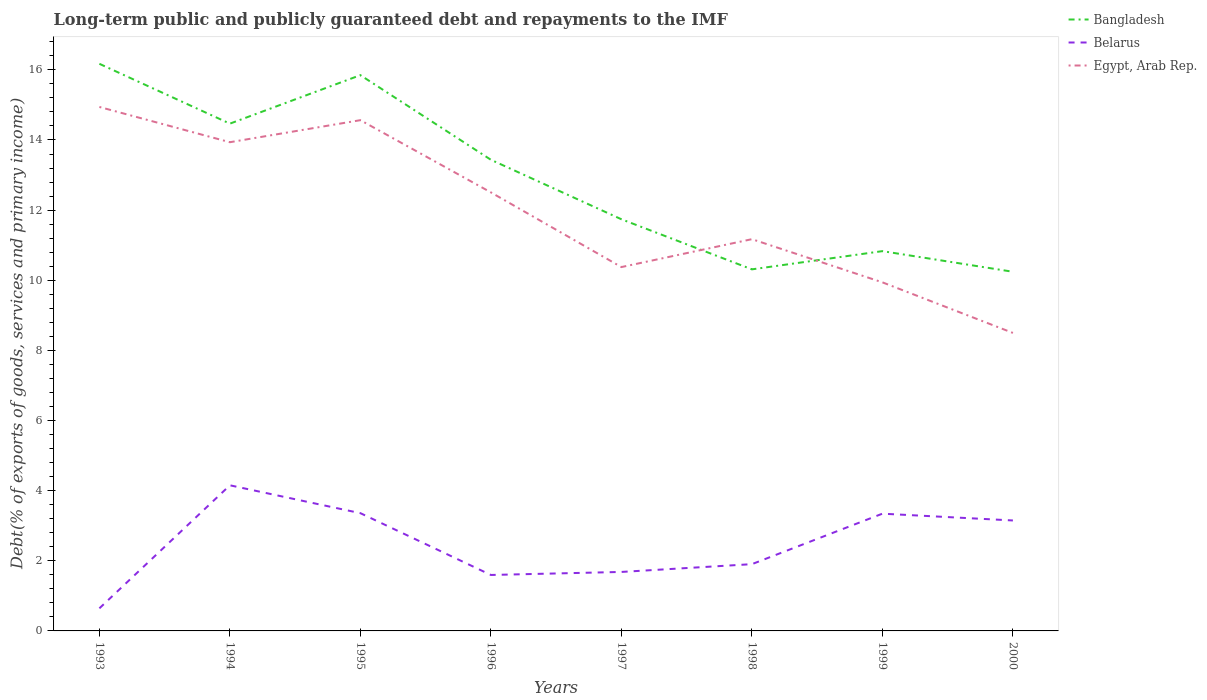How many different coloured lines are there?
Provide a short and direct response. 3. Across all years, what is the maximum debt and repayments in Egypt, Arab Rep.?
Make the answer very short. 8.5. What is the total debt and repayments in Egypt, Arab Rep. in the graph?
Make the answer very short. 6.07. What is the difference between the highest and the second highest debt and repayments in Bangladesh?
Offer a very short reply. 5.93. What is the difference between the highest and the lowest debt and repayments in Bangladesh?
Offer a very short reply. 4. How many years are there in the graph?
Keep it short and to the point. 8. Does the graph contain any zero values?
Offer a very short reply. No. How are the legend labels stacked?
Ensure brevity in your answer.  Vertical. What is the title of the graph?
Offer a terse response. Long-term public and publicly guaranteed debt and repayments to the IMF. What is the label or title of the X-axis?
Provide a short and direct response. Years. What is the label or title of the Y-axis?
Give a very brief answer. Debt(% of exports of goods, services and primary income). What is the Debt(% of exports of goods, services and primary income) of Bangladesh in 1993?
Your response must be concise. 16.17. What is the Debt(% of exports of goods, services and primary income) in Belarus in 1993?
Ensure brevity in your answer.  0.64. What is the Debt(% of exports of goods, services and primary income) of Egypt, Arab Rep. in 1993?
Your answer should be compact. 14.94. What is the Debt(% of exports of goods, services and primary income) of Bangladesh in 1994?
Offer a terse response. 14.47. What is the Debt(% of exports of goods, services and primary income) of Belarus in 1994?
Ensure brevity in your answer.  4.15. What is the Debt(% of exports of goods, services and primary income) of Egypt, Arab Rep. in 1994?
Provide a succinct answer. 13.94. What is the Debt(% of exports of goods, services and primary income) in Bangladesh in 1995?
Provide a succinct answer. 15.85. What is the Debt(% of exports of goods, services and primary income) in Belarus in 1995?
Offer a very short reply. 3.36. What is the Debt(% of exports of goods, services and primary income) of Egypt, Arab Rep. in 1995?
Offer a terse response. 14.56. What is the Debt(% of exports of goods, services and primary income) of Bangladesh in 1996?
Provide a short and direct response. 13.44. What is the Debt(% of exports of goods, services and primary income) of Belarus in 1996?
Give a very brief answer. 1.6. What is the Debt(% of exports of goods, services and primary income) of Egypt, Arab Rep. in 1996?
Ensure brevity in your answer.  12.51. What is the Debt(% of exports of goods, services and primary income) in Bangladesh in 1997?
Make the answer very short. 11.74. What is the Debt(% of exports of goods, services and primary income) in Belarus in 1997?
Your response must be concise. 1.68. What is the Debt(% of exports of goods, services and primary income) of Egypt, Arab Rep. in 1997?
Your response must be concise. 10.38. What is the Debt(% of exports of goods, services and primary income) in Bangladesh in 1998?
Ensure brevity in your answer.  10.31. What is the Debt(% of exports of goods, services and primary income) in Belarus in 1998?
Provide a short and direct response. 1.9. What is the Debt(% of exports of goods, services and primary income) in Egypt, Arab Rep. in 1998?
Provide a short and direct response. 11.17. What is the Debt(% of exports of goods, services and primary income) of Bangladesh in 1999?
Your response must be concise. 10.83. What is the Debt(% of exports of goods, services and primary income) of Belarus in 1999?
Provide a short and direct response. 3.34. What is the Debt(% of exports of goods, services and primary income) of Egypt, Arab Rep. in 1999?
Your answer should be very brief. 9.94. What is the Debt(% of exports of goods, services and primary income) in Bangladesh in 2000?
Offer a terse response. 10.24. What is the Debt(% of exports of goods, services and primary income) in Belarus in 2000?
Keep it short and to the point. 3.15. What is the Debt(% of exports of goods, services and primary income) in Egypt, Arab Rep. in 2000?
Keep it short and to the point. 8.5. Across all years, what is the maximum Debt(% of exports of goods, services and primary income) of Bangladesh?
Your answer should be very brief. 16.17. Across all years, what is the maximum Debt(% of exports of goods, services and primary income) of Belarus?
Give a very brief answer. 4.15. Across all years, what is the maximum Debt(% of exports of goods, services and primary income) in Egypt, Arab Rep.?
Keep it short and to the point. 14.94. Across all years, what is the minimum Debt(% of exports of goods, services and primary income) of Bangladesh?
Offer a very short reply. 10.24. Across all years, what is the minimum Debt(% of exports of goods, services and primary income) of Belarus?
Your response must be concise. 0.64. Across all years, what is the minimum Debt(% of exports of goods, services and primary income) in Egypt, Arab Rep.?
Your answer should be compact. 8.5. What is the total Debt(% of exports of goods, services and primary income) of Bangladesh in the graph?
Offer a very short reply. 103.04. What is the total Debt(% of exports of goods, services and primary income) of Belarus in the graph?
Provide a short and direct response. 19.83. What is the total Debt(% of exports of goods, services and primary income) of Egypt, Arab Rep. in the graph?
Your answer should be very brief. 95.93. What is the difference between the Debt(% of exports of goods, services and primary income) in Bangladesh in 1993 and that in 1994?
Provide a short and direct response. 1.71. What is the difference between the Debt(% of exports of goods, services and primary income) of Belarus in 1993 and that in 1994?
Your response must be concise. -3.51. What is the difference between the Debt(% of exports of goods, services and primary income) in Egypt, Arab Rep. in 1993 and that in 1994?
Keep it short and to the point. 1.01. What is the difference between the Debt(% of exports of goods, services and primary income) of Bangladesh in 1993 and that in 1995?
Your answer should be compact. 0.32. What is the difference between the Debt(% of exports of goods, services and primary income) of Belarus in 1993 and that in 1995?
Your answer should be very brief. -2.71. What is the difference between the Debt(% of exports of goods, services and primary income) of Egypt, Arab Rep. in 1993 and that in 1995?
Ensure brevity in your answer.  0.38. What is the difference between the Debt(% of exports of goods, services and primary income) in Bangladesh in 1993 and that in 1996?
Keep it short and to the point. 2.74. What is the difference between the Debt(% of exports of goods, services and primary income) in Belarus in 1993 and that in 1996?
Your response must be concise. -0.95. What is the difference between the Debt(% of exports of goods, services and primary income) in Egypt, Arab Rep. in 1993 and that in 1996?
Make the answer very short. 2.44. What is the difference between the Debt(% of exports of goods, services and primary income) in Bangladesh in 1993 and that in 1997?
Keep it short and to the point. 4.43. What is the difference between the Debt(% of exports of goods, services and primary income) of Belarus in 1993 and that in 1997?
Make the answer very short. -1.04. What is the difference between the Debt(% of exports of goods, services and primary income) in Egypt, Arab Rep. in 1993 and that in 1997?
Your answer should be very brief. 4.57. What is the difference between the Debt(% of exports of goods, services and primary income) in Bangladesh in 1993 and that in 1998?
Give a very brief answer. 5.86. What is the difference between the Debt(% of exports of goods, services and primary income) in Belarus in 1993 and that in 1998?
Provide a short and direct response. -1.26. What is the difference between the Debt(% of exports of goods, services and primary income) in Egypt, Arab Rep. in 1993 and that in 1998?
Your answer should be compact. 3.77. What is the difference between the Debt(% of exports of goods, services and primary income) of Bangladesh in 1993 and that in 1999?
Offer a very short reply. 5.34. What is the difference between the Debt(% of exports of goods, services and primary income) of Belarus in 1993 and that in 1999?
Make the answer very short. -2.7. What is the difference between the Debt(% of exports of goods, services and primary income) of Egypt, Arab Rep. in 1993 and that in 1999?
Give a very brief answer. 5. What is the difference between the Debt(% of exports of goods, services and primary income) in Bangladesh in 1993 and that in 2000?
Offer a very short reply. 5.93. What is the difference between the Debt(% of exports of goods, services and primary income) in Belarus in 1993 and that in 2000?
Ensure brevity in your answer.  -2.51. What is the difference between the Debt(% of exports of goods, services and primary income) of Egypt, Arab Rep. in 1993 and that in 2000?
Make the answer very short. 6.44. What is the difference between the Debt(% of exports of goods, services and primary income) in Bangladesh in 1994 and that in 1995?
Your response must be concise. -1.38. What is the difference between the Debt(% of exports of goods, services and primary income) of Belarus in 1994 and that in 1995?
Your answer should be very brief. 0.79. What is the difference between the Debt(% of exports of goods, services and primary income) of Egypt, Arab Rep. in 1994 and that in 1995?
Keep it short and to the point. -0.63. What is the difference between the Debt(% of exports of goods, services and primary income) of Bangladesh in 1994 and that in 1996?
Provide a succinct answer. 1.03. What is the difference between the Debt(% of exports of goods, services and primary income) in Belarus in 1994 and that in 1996?
Your answer should be very brief. 2.56. What is the difference between the Debt(% of exports of goods, services and primary income) of Egypt, Arab Rep. in 1994 and that in 1996?
Your answer should be compact. 1.43. What is the difference between the Debt(% of exports of goods, services and primary income) of Bangladesh in 1994 and that in 1997?
Provide a succinct answer. 2.73. What is the difference between the Debt(% of exports of goods, services and primary income) in Belarus in 1994 and that in 1997?
Your response must be concise. 2.47. What is the difference between the Debt(% of exports of goods, services and primary income) in Egypt, Arab Rep. in 1994 and that in 1997?
Ensure brevity in your answer.  3.56. What is the difference between the Debt(% of exports of goods, services and primary income) of Bangladesh in 1994 and that in 1998?
Your answer should be compact. 4.16. What is the difference between the Debt(% of exports of goods, services and primary income) in Belarus in 1994 and that in 1998?
Make the answer very short. 2.25. What is the difference between the Debt(% of exports of goods, services and primary income) of Egypt, Arab Rep. in 1994 and that in 1998?
Offer a very short reply. 2.76. What is the difference between the Debt(% of exports of goods, services and primary income) of Bangladesh in 1994 and that in 1999?
Ensure brevity in your answer.  3.64. What is the difference between the Debt(% of exports of goods, services and primary income) in Belarus in 1994 and that in 1999?
Offer a very short reply. 0.81. What is the difference between the Debt(% of exports of goods, services and primary income) in Egypt, Arab Rep. in 1994 and that in 1999?
Offer a terse response. 4. What is the difference between the Debt(% of exports of goods, services and primary income) of Bangladesh in 1994 and that in 2000?
Keep it short and to the point. 4.22. What is the difference between the Debt(% of exports of goods, services and primary income) in Belarus in 1994 and that in 2000?
Your response must be concise. 1. What is the difference between the Debt(% of exports of goods, services and primary income) of Egypt, Arab Rep. in 1994 and that in 2000?
Give a very brief answer. 5.44. What is the difference between the Debt(% of exports of goods, services and primary income) in Bangladesh in 1995 and that in 1996?
Offer a terse response. 2.41. What is the difference between the Debt(% of exports of goods, services and primary income) in Belarus in 1995 and that in 1996?
Your answer should be compact. 1.76. What is the difference between the Debt(% of exports of goods, services and primary income) in Egypt, Arab Rep. in 1995 and that in 1996?
Give a very brief answer. 2.06. What is the difference between the Debt(% of exports of goods, services and primary income) in Bangladesh in 1995 and that in 1997?
Offer a very short reply. 4.11. What is the difference between the Debt(% of exports of goods, services and primary income) of Belarus in 1995 and that in 1997?
Ensure brevity in your answer.  1.68. What is the difference between the Debt(% of exports of goods, services and primary income) of Egypt, Arab Rep. in 1995 and that in 1997?
Give a very brief answer. 4.19. What is the difference between the Debt(% of exports of goods, services and primary income) of Bangladesh in 1995 and that in 1998?
Your answer should be very brief. 5.54. What is the difference between the Debt(% of exports of goods, services and primary income) in Belarus in 1995 and that in 1998?
Provide a succinct answer. 1.45. What is the difference between the Debt(% of exports of goods, services and primary income) in Egypt, Arab Rep. in 1995 and that in 1998?
Give a very brief answer. 3.39. What is the difference between the Debt(% of exports of goods, services and primary income) in Bangladesh in 1995 and that in 1999?
Give a very brief answer. 5.02. What is the difference between the Debt(% of exports of goods, services and primary income) in Belarus in 1995 and that in 1999?
Make the answer very short. 0.01. What is the difference between the Debt(% of exports of goods, services and primary income) in Egypt, Arab Rep. in 1995 and that in 1999?
Provide a short and direct response. 4.62. What is the difference between the Debt(% of exports of goods, services and primary income) of Bangladesh in 1995 and that in 2000?
Provide a short and direct response. 5.61. What is the difference between the Debt(% of exports of goods, services and primary income) in Belarus in 1995 and that in 2000?
Ensure brevity in your answer.  0.21. What is the difference between the Debt(% of exports of goods, services and primary income) in Egypt, Arab Rep. in 1995 and that in 2000?
Ensure brevity in your answer.  6.07. What is the difference between the Debt(% of exports of goods, services and primary income) of Bangladesh in 1996 and that in 1997?
Give a very brief answer. 1.7. What is the difference between the Debt(% of exports of goods, services and primary income) in Belarus in 1996 and that in 1997?
Your answer should be very brief. -0.09. What is the difference between the Debt(% of exports of goods, services and primary income) of Egypt, Arab Rep. in 1996 and that in 1997?
Make the answer very short. 2.13. What is the difference between the Debt(% of exports of goods, services and primary income) of Bangladesh in 1996 and that in 1998?
Your answer should be compact. 3.12. What is the difference between the Debt(% of exports of goods, services and primary income) in Belarus in 1996 and that in 1998?
Make the answer very short. -0.31. What is the difference between the Debt(% of exports of goods, services and primary income) of Egypt, Arab Rep. in 1996 and that in 1998?
Keep it short and to the point. 1.33. What is the difference between the Debt(% of exports of goods, services and primary income) in Bangladesh in 1996 and that in 1999?
Provide a short and direct response. 2.61. What is the difference between the Debt(% of exports of goods, services and primary income) in Belarus in 1996 and that in 1999?
Give a very brief answer. -1.75. What is the difference between the Debt(% of exports of goods, services and primary income) in Egypt, Arab Rep. in 1996 and that in 1999?
Offer a very short reply. 2.56. What is the difference between the Debt(% of exports of goods, services and primary income) of Bangladesh in 1996 and that in 2000?
Your response must be concise. 3.19. What is the difference between the Debt(% of exports of goods, services and primary income) of Belarus in 1996 and that in 2000?
Provide a short and direct response. -1.55. What is the difference between the Debt(% of exports of goods, services and primary income) of Egypt, Arab Rep. in 1996 and that in 2000?
Ensure brevity in your answer.  4.01. What is the difference between the Debt(% of exports of goods, services and primary income) of Bangladesh in 1997 and that in 1998?
Give a very brief answer. 1.43. What is the difference between the Debt(% of exports of goods, services and primary income) in Belarus in 1997 and that in 1998?
Make the answer very short. -0.22. What is the difference between the Debt(% of exports of goods, services and primary income) of Egypt, Arab Rep. in 1997 and that in 1998?
Give a very brief answer. -0.8. What is the difference between the Debt(% of exports of goods, services and primary income) of Bangladesh in 1997 and that in 1999?
Keep it short and to the point. 0.91. What is the difference between the Debt(% of exports of goods, services and primary income) in Belarus in 1997 and that in 1999?
Provide a short and direct response. -1.66. What is the difference between the Debt(% of exports of goods, services and primary income) in Egypt, Arab Rep. in 1997 and that in 1999?
Offer a terse response. 0.44. What is the difference between the Debt(% of exports of goods, services and primary income) in Bangladesh in 1997 and that in 2000?
Your answer should be very brief. 1.5. What is the difference between the Debt(% of exports of goods, services and primary income) in Belarus in 1997 and that in 2000?
Make the answer very short. -1.47. What is the difference between the Debt(% of exports of goods, services and primary income) in Egypt, Arab Rep. in 1997 and that in 2000?
Make the answer very short. 1.88. What is the difference between the Debt(% of exports of goods, services and primary income) of Bangladesh in 1998 and that in 1999?
Your response must be concise. -0.52. What is the difference between the Debt(% of exports of goods, services and primary income) in Belarus in 1998 and that in 1999?
Offer a terse response. -1.44. What is the difference between the Debt(% of exports of goods, services and primary income) of Egypt, Arab Rep. in 1998 and that in 1999?
Offer a terse response. 1.23. What is the difference between the Debt(% of exports of goods, services and primary income) in Bangladesh in 1998 and that in 2000?
Offer a terse response. 0.07. What is the difference between the Debt(% of exports of goods, services and primary income) in Belarus in 1998 and that in 2000?
Provide a short and direct response. -1.25. What is the difference between the Debt(% of exports of goods, services and primary income) of Egypt, Arab Rep. in 1998 and that in 2000?
Provide a succinct answer. 2.67. What is the difference between the Debt(% of exports of goods, services and primary income) in Bangladesh in 1999 and that in 2000?
Offer a very short reply. 0.59. What is the difference between the Debt(% of exports of goods, services and primary income) of Belarus in 1999 and that in 2000?
Give a very brief answer. 0.19. What is the difference between the Debt(% of exports of goods, services and primary income) of Egypt, Arab Rep. in 1999 and that in 2000?
Your answer should be very brief. 1.44. What is the difference between the Debt(% of exports of goods, services and primary income) in Bangladesh in 1993 and the Debt(% of exports of goods, services and primary income) in Belarus in 1994?
Your response must be concise. 12.02. What is the difference between the Debt(% of exports of goods, services and primary income) in Bangladesh in 1993 and the Debt(% of exports of goods, services and primary income) in Egypt, Arab Rep. in 1994?
Your answer should be very brief. 2.24. What is the difference between the Debt(% of exports of goods, services and primary income) in Belarus in 1993 and the Debt(% of exports of goods, services and primary income) in Egypt, Arab Rep. in 1994?
Give a very brief answer. -13.29. What is the difference between the Debt(% of exports of goods, services and primary income) in Bangladesh in 1993 and the Debt(% of exports of goods, services and primary income) in Belarus in 1995?
Give a very brief answer. 12.81. What is the difference between the Debt(% of exports of goods, services and primary income) of Bangladesh in 1993 and the Debt(% of exports of goods, services and primary income) of Egypt, Arab Rep. in 1995?
Ensure brevity in your answer.  1.61. What is the difference between the Debt(% of exports of goods, services and primary income) of Belarus in 1993 and the Debt(% of exports of goods, services and primary income) of Egypt, Arab Rep. in 1995?
Your answer should be compact. -13.92. What is the difference between the Debt(% of exports of goods, services and primary income) in Bangladesh in 1993 and the Debt(% of exports of goods, services and primary income) in Belarus in 1996?
Your answer should be compact. 14.58. What is the difference between the Debt(% of exports of goods, services and primary income) in Bangladesh in 1993 and the Debt(% of exports of goods, services and primary income) in Egypt, Arab Rep. in 1996?
Provide a succinct answer. 3.67. What is the difference between the Debt(% of exports of goods, services and primary income) in Belarus in 1993 and the Debt(% of exports of goods, services and primary income) in Egypt, Arab Rep. in 1996?
Offer a very short reply. -11.86. What is the difference between the Debt(% of exports of goods, services and primary income) in Bangladesh in 1993 and the Debt(% of exports of goods, services and primary income) in Belarus in 1997?
Offer a terse response. 14.49. What is the difference between the Debt(% of exports of goods, services and primary income) in Bangladesh in 1993 and the Debt(% of exports of goods, services and primary income) in Egypt, Arab Rep. in 1997?
Keep it short and to the point. 5.8. What is the difference between the Debt(% of exports of goods, services and primary income) in Belarus in 1993 and the Debt(% of exports of goods, services and primary income) in Egypt, Arab Rep. in 1997?
Your response must be concise. -9.73. What is the difference between the Debt(% of exports of goods, services and primary income) in Bangladesh in 1993 and the Debt(% of exports of goods, services and primary income) in Belarus in 1998?
Your answer should be compact. 14.27. What is the difference between the Debt(% of exports of goods, services and primary income) in Bangladesh in 1993 and the Debt(% of exports of goods, services and primary income) in Egypt, Arab Rep. in 1998?
Your response must be concise. 5. What is the difference between the Debt(% of exports of goods, services and primary income) of Belarus in 1993 and the Debt(% of exports of goods, services and primary income) of Egypt, Arab Rep. in 1998?
Your answer should be compact. -10.53. What is the difference between the Debt(% of exports of goods, services and primary income) in Bangladesh in 1993 and the Debt(% of exports of goods, services and primary income) in Belarus in 1999?
Offer a terse response. 12.83. What is the difference between the Debt(% of exports of goods, services and primary income) of Bangladesh in 1993 and the Debt(% of exports of goods, services and primary income) of Egypt, Arab Rep. in 1999?
Provide a succinct answer. 6.23. What is the difference between the Debt(% of exports of goods, services and primary income) in Belarus in 1993 and the Debt(% of exports of goods, services and primary income) in Egypt, Arab Rep. in 1999?
Your answer should be compact. -9.3. What is the difference between the Debt(% of exports of goods, services and primary income) in Bangladesh in 1993 and the Debt(% of exports of goods, services and primary income) in Belarus in 2000?
Keep it short and to the point. 13.02. What is the difference between the Debt(% of exports of goods, services and primary income) of Bangladesh in 1993 and the Debt(% of exports of goods, services and primary income) of Egypt, Arab Rep. in 2000?
Your answer should be compact. 7.67. What is the difference between the Debt(% of exports of goods, services and primary income) of Belarus in 1993 and the Debt(% of exports of goods, services and primary income) of Egypt, Arab Rep. in 2000?
Make the answer very short. -7.85. What is the difference between the Debt(% of exports of goods, services and primary income) of Bangladesh in 1994 and the Debt(% of exports of goods, services and primary income) of Belarus in 1995?
Ensure brevity in your answer.  11.11. What is the difference between the Debt(% of exports of goods, services and primary income) of Bangladesh in 1994 and the Debt(% of exports of goods, services and primary income) of Egypt, Arab Rep. in 1995?
Keep it short and to the point. -0.1. What is the difference between the Debt(% of exports of goods, services and primary income) in Belarus in 1994 and the Debt(% of exports of goods, services and primary income) in Egypt, Arab Rep. in 1995?
Your response must be concise. -10.41. What is the difference between the Debt(% of exports of goods, services and primary income) of Bangladesh in 1994 and the Debt(% of exports of goods, services and primary income) of Belarus in 1996?
Give a very brief answer. 12.87. What is the difference between the Debt(% of exports of goods, services and primary income) of Bangladesh in 1994 and the Debt(% of exports of goods, services and primary income) of Egypt, Arab Rep. in 1996?
Keep it short and to the point. 1.96. What is the difference between the Debt(% of exports of goods, services and primary income) of Belarus in 1994 and the Debt(% of exports of goods, services and primary income) of Egypt, Arab Rep. in 1996?
Your answer should be very brief. -8.35. What is the difference between the Debt(% of exports of goods, services and primary income) in Bangladesh in 1994 and the Debt(% of exports of goods, services and primary income) in Belarus in 1997?
Offer a terse response. 12.78. What is the difference between the Debt(% of exports of goods, services and primary income) of Bangladesh in 1994 and the Debt(% of exports of goods, services and primary income) of Egypt, Arab Rep. in 1997?
Keep it short and to the point. 4.09. What is the difference between the Debt(% of exports of goods, services and primary income) in Belarus in 1994 and the Debt(% of exports of goods, services and primary income) in Egypt, Arab Rep. in 1997?
Your answer should be compact. -6.22. What is the difference between the Debt(% of exports of goods, services and primary income) of Bangladesh in 1994 and the Debt(% of exports of goods, services and primary income) of Belarus in 1998?
Keep it short and to the point. 12.56. What is the difference between the Debt(% of exports of goods, services and primary income) of Bangladesh in 1994 and the Debt(% of exports of goods, services and primary income) of Egypt, Arab Rep. in 1998?
Make the answer very short. 3.29. What is the difference between the Debt(% of exports of goods, services and primary income) of Belarus in 1994 and the Debt(% of exports of goods, services and primary income) of Egypt, Arab Rep. in 1998?
Keep it short and to the point. -7.02. What is the difference between the Debt(% of exports of goods, services and primary income) in Bangladesh in 1994 and the Debt(% of exports of goods, services and primary income) in Belarus in 1999?
Your response must be concise. 11.12. What is the difference between the Debt(% of exports of goods, services and primary income) in Bangladesh in 1994 and the Debt(% of exports of goods, services and primary income) in Egypt, Arab Rep. in 1999?
Your answer should be very brief. 4.53. What is the difference between the Debt(% of exports of goods, services and primary income) in Belarus in 1994 and the Debt(% of exports of goods, services and primary income) in Egypt, Arab Rep. in 1999?
Make the answer very short. -5.79. What is the difference between the Debt(% of exports of goods, services and primary income) in Bangladesh in 1994 and the Debt(% of exports of goods, services and primary income) in Belarus in 2000?
Your answer should be very brief. 11.32. What is the difference between the Debt(% of exports of goods, services and primary income) of Bangladesh in 1994 and the Debt(% of exports of goods, services and primary income) of Egypt, Arab Rep. in 2000?
Offer a terse response. 5.97. What is the difference between the Debt(% of exports of goods, services and primary income) of Belarus in 1994 and the Debt(% of exports of goods, services and primary income) of Egypt, Arab Rep. in 2000?
Ensure brevity in your answer.  -4.35. What is the difference between the Debt(% of exports of goods, services and primary income) of Bangladesh in 1995 and the Debt(% of exports of goods, services and primary income) of Belarus in 1996?
Keep it short and to the point. 14.25. What is the difference between the Debt(% of exports of goods, services and primary income) in Bangladesh in 1995 and the Debt(% of exports of goods, services and primary income) in Egypt, Arab Rep. in 1996?
Your answer should be very brief. 3.34. What is the difference between the Debt(% of exports of goods, services and primary income) in Belarus in 1995 and the Debt(% of exports of goods, services and primary income) in Egypt, Arab Rep. in 1996?
Provide a short and direct response. -9.15. What is the difference between the Debt(% of exports of goods, services and primary income) of Bangladesh in 1995 and the Debt(% of exports of goods, services and primary income) of Belarus in 1997?
Provide a short and direct response. 14.17. What is the difference between the Debt(% of exports of goods, services and primary income) in Bangladesh in 1995 and the Debt(% of exports of goods, services and primary income) in Egypt, Arab Rep. in 1997?
Provide a short and direct response. 5.47. What is the difference between the Debt(% of exports of goods, services and primary income) in Belarus in 1995 and the Debt(% of exports of goods, services and primary income) in Egypt, Arab Rep. in 1997?
Your answer should be very brief. -7.02. What is the difference between the Debt(% of exports of goods, services and primary income) of Bangladesh in 1995 and the Debt(% of exports of goods, services and primary income) of Belarus in 1998?
Give a very brief answer. 13.94. What is the difference between the Debt(% of exports of goods, services and primary income) in Bangladesh in 1995 and the Debt(% of exports of goods, services and primary income) in Egypt, Arab Rep. in 1998?
Give a very brief answer. 4.68. What is the difference between the Debt(% of exports of goods, services and primary income) in Belarus in 1995 and the Debt(% of exports of goods, services and primary income) in Egypt, Arab Rep. in 1998?
Make the answer very short. -7.81. What is the difference between the Debt(% of exports of goods, services and primary income) of Bangladesh in 1995 and the Debt(% of exports of goods, services and primary income) of Belarus in 1999?
Provide a short and direct response. 12.5. What is the difference between the Debt(% of exports of goods, services and primary income) in Bangladesh in 1995 and the Debt(% of exports of goods, services and primary income) in Egypt, Arab Rep. in 1999?
Keep it short and to the point. 5.91. What is the difference between the Debt(% of exports of goods, services and primary income) in Belarus in 1995 and the Debt(% of exports of goods, services and primary income) in Egypt, Arab Rep. in 1999?
Your answer should be very brief. -6.58. What is the difference between the Debt(% of exports of goods, services and primary income) in Bangladesh in 1995 and the Debt(% of exports of goods, services and primary income) in Belarus in 2000?
Offer a very short reply. 12.7. What is the difference between the Debt(% of exports of goods, services and primary income) of Bangladesh in 1995 and the Debt(% of exports of goods, services and primary income) of Egypt, Arab Rep. in 2000?
Ensure brevity in your answer.  7.35. What is the difference between the Debt(% of exports of goods, services and primary income) in Belarus in 1995 and the Debt(% of exports of goods, services and primary income) in Egypt, Arab Rep. in 2000?
Keep it short and to the point. -5.14. What is the difference between the Debt(% of exports of goods, services and primary income) in Bangladesh in 1996 and the Debt(% of exports of goods, services and primary income) in Belarus in 1997?
Give a very brief answer. 11.75. What is the difference between the Debt(% of exports of goods, services and primary income) of Bangladesh in 1996 and the Debt(% of exports of goods, services and primary income) of Egypt, Arab Rep. in 1997?
Provide a succinct answer. 3.06. What is the difference between the Debt(% of exports of goods, services and primary income) in Belarus in 1996 and the Debt(% of exports of goods, services and primary income) in Egypt, Arab Rep. in 1997?
Provide a short and direct response. -8.78. What is the difference between the Debt(% of exports of goods, services and primary income) of Bangladesh in 1996 and the Debt(% of exports of goods, services and primary income) of Belarus in 1998?
Ensure brevity in your answer.  11.53. What is the difference between the Debt(% of exports of goods, services and primary income) of Bangladesh in 1996 and the Debt(% of exports of goods, services and primary income) of Egypt, Arab Rep. in 1998?
Your answer should be compact. 2.26. What is the difference between the Debt(% of exports of goods, services and primary income) of Belarus in 1996 and the Debt(% of exports of goods, services and primary income) of Egypt, Arab Rep. in 1998?
Make the answer very short. -9.58. What is the difference between the Debt(% of exports of goods, services and primary income) of Bangladesh in 1996 and the Debt(% of exports of goods, services and primary income) of Belarus in 1999?
Your response must be concise. 10.09. What is the difference between the Debt(% of exports of goods, services and primary income) of Bangladesh in 1996 and the Debt(% of exports of goods, services and primary income) of Egypt, Arab Rep. in 1999?
Your answer should be compact. 3.5. What is the difference between the Debt(% of exports of goods, services and primary income) of Belarus in 1996 and the Debt(% of exports of goods, services and primary income) of Egypt, Arab Rep. in 1999?
Offer a terse response. -8.34. What is the difference between the Debt(% of exports of goods, services and primary income) of Bangladesh in 1996 and the Debt(% of exports of goods, services and primary income) of Belarus in 2000?
Your answer should be compact. 10.29. What is the difference between the Debt(% of exports of goods, services and primary income) of Bangladesh in 1996 and the Debt(% of exports of goods, services and primary income) of Egypt, Arab Rep. in 2000?
Give a very brief answer. 4.94. What is the difference between the Debt(% of exports of goods, services and primary income) of Belarus in 1996 and the Debt(% of exports of goods, services and primary income) of Egypt, Arab Rep. in 2000?
Your answer should be very brief. -6.9. What is the difference between the Debt(% of exports of goods, services and primary income) of Bangladesh in 1997 and the Debt(% of exports of goods, services and primary income) of Belarus in 1998?
Make the answer very short. 9.84. What is the difference between the Debt(% of exports of goods, services and primary income) of Bangladesh in 1997 and the Debt(% of exports of goods, services and primary income) of Egypt, Arab Rep. in 1998?
Make the answer very short. 0.57. What is the difference between the Debt(% of exports of goods, services and primary income) of Belarus in 1997 and the Debt(% of exports of goods, services and primary income) of Egypt, Arab Rep. in 1998?
Your answer should be compact. -9.49. What is the difference between the Debt(% of exports of goods, services and primary income) of Bangladesh in 1997 and the Debt(% of exports of goods, services and primary income) of Belarus in 1999?
Make the answer very short. 8.4. What is the difference between the Debt(% of exports of goods, services and primary income) of Bangladesh in 1997 and the Debt(% of exports of goods, services and primary income) of Egypt, Arab Rep. in 1999?
Provide a short and direct response. 1.8. What is the difference between the Debt(% of exports of goods, services and primary income) of Belarus in 1997 and the Debt(% of exports of goods, services and primary income) of Egypt, Arab Rep. in 1999?
Offer a very short reply. -8.26. What is the difference between the Debt(% of exports of goods, services and primary income) of Bangladesh in 1997 and the Debt(% of exports of goods, services and primary income) of Belarus in 2000?
Your response must be concise. 8.59. What is the difference between the Debt(% of exports of goods, services and primary income) in Bangladesh in 1997 and the Debt(% of exports of goods, services and primary income) in Egypt, Arab Rep. in 2000?
Your response must be concise. 3.24. What is the difference between the Debt(% of exports of goods, services and primary income) of Belarus in 1997 and the Debt(% of exports of goods, services and primary income) of Egypt, Arab Rep. in 2000?
Your answer should be very brief. -6.82. What is the difference between the Debt(% of exports of goods, services and primary income) of Bangladesh in 1998 and the Debt(% of exports of goods, services and primary income) of Belarus in 1999?
Ensure brevity in your answer.  6.97. What is the difference between the Debt(% of exports of goods, services and primary income) in Bangladesh in 1998 and the Debt(% of exports of goods, services and primary income) in Egypt, Arab Rep. in 1999?
Provide a succinct answer. 0.37. What is the difference between the Debt(% of exports of goods, services and primary income) in Belarus in 1998 and the Debt(% of exports of goods, services and primary income) in Egypt, Arab Rep. in 1999?
Give a very brief answer. -8.04. What is the difference between the Debt(% of exports of goods, services and primary income) of Bangladesh in 1998 and the Debt(% of exports of goods, services and primary income) of Belarus in 2000?
Provide a short and direct response. 7.16. What is the difference between the Debt(% of exports of goods, services and primary income) of Bangladesh in 1998 and the Debt(% of exports of goods, services and primary income) of Egypt, Arab Rep. in 2000?
Your answer should be compact. 1.81. What is the difference between the Debt(% of exports of goods, services and primary income) of Belarus in 1998 and the Debt(% of exports of goods, services and primary income) of Egypt, Arab Rep. in 2000?
Provide a succinct answer. -6.59. What is the difference between the Debt(% of exports of goods, services and primary income) of Bangladesh in 1999 and the Debt(% of exports of goods, services and primary income) of Belarus in 2000?
Make the answer very short. 7.68. What is the difference between the Debt(% of exports of goods, services and primary income) of Bangladesh in 1999 and the Debt(% of exports of goods, services and primary income) of Egypt, Arab Rep. in 2000?
Keep it short and to the point. 2.33. What is the difference between the Debt(% of exports of goods, services and primary income) in Belarus in 1999 and the Debt(% of exports of goods, services and primary income) in Egypt, Arab Rep. in 2000?
Your answer should be compact. -5.15. What is the average Debt(% of exports of goods, services and primary income) in Bangladesh per year?
Make the answer very short. 12.88. What is the average Debt(% of exports of goods, services and primary income) in Belarus per year?
Keep it short and to the point. 2.48. What is the average Debt(% of exports of goods, services and primary income) of Egypt, Arab Rep. per year?
Make the answer very short. 11.99. In the year 1993, what is the difference between the Debt(% of exports of goods, services and primary income) of Bangladesh and Debt(% of exports of goods, services and primary income) of Belarus?
Your response must be concise. 15.53. In the year 1993, what is the difference between the Debt(% of exports of goods, services and primary income) in Bangladesh and Debt(% of exports of goods, services and primary income) in Egypt, Arab Rep.?
Your response must be concise. 1.23. In the year 1993, what is the difference between the Debt(% of exports of goods, services and primary income) of Belarus and Debt(% of exports of goods, services and primary income) of Egypt, Arab Rep.?
Provide a short and direct response. -14.3. In the year 1994, what is the difference between the Debt(% of exports of goods, services and primary income) in Bangladesh and Debt(% of exports of goods, services and primary income) in Belarus?
Your answer should be very brief. 10.31. In the year 1994, what is the difference between the Debt(% of exports of goods, services and primary income) of Bangladesh and Debt(% of exports of goods, services and primary income) of Egypt, Arab Rep.?
Make the answer very short. 0.53. In the year 1994, what is the difference between the Debt(% of exports of goods, services and primary income) in Belarus and Debt(% of exports of goods, services and primary income) in Egypt, Arab Rep.?
Provide a short and direct response. -9.78. In the year 1995, what is the difference between the Debt(% of exports of goods, services and primary income) in Bangladesh and Debt(% of exports of goods, services and primary income) in Belarus?
Offer a very short reply. 12.49. In the year 1995, what is the difference between the Debt(% of exports of goods, services and primary income) in Bangladesh and Debt(% of exports of goods, services and primary income) in Egypt, Arab Rep.?
Provide a short and direct response. 1.28. In the year 1995, what is the difference between the Debt(% of exports of goods, services and primary income) in Belarus and Debt(% of exports of goods, services and primary income) in Egypt, Arab Rep.?
Offer a terse response. -11.21. In the year 1996, what is the difference between the Debt(% of exports of goods, services and primary income) in Bangladesh and Debt(% of exports of goods, services and primary income) in Belarus?
Your response must be concise. 11.84. In the year 1996, what is the difference between the Debt(% of exports of goods, services and primary income) in Belarus and Debt(% of exports of goods, services and primary income) in Egypt, Arab Rep.?
Provide a short and direct response. -10.91. In the year 1997, what is the difference between the Debt(% of exports of goods, services and primary income) in Bangladesh and Debt(% of exports of goods, services and primary income) in Belarus?
Provide a succinct answer. 10.06. In the year 1997, what is the difference between the Debt(% of exports of goods, services and primary income) in Bangladesh and Debt(% of exports of goods, services and primary income) in Egypt, Arab Rep.?
Keep it short and to the point. 1.36. In the year 1997, what is the difference between the Debt(% of exports of goods, services and primary income) of Belarus and Debt(% of exports of goods, services and primary income) of Egypt, Arab Rep.?
Your answer should be compact. -8.69. In the year 1998, what is the difference between the Debt(% of exports of goods, services and primary income) of Bangladesh and Debt(% of exports of goods, services and primary income) of Belarus?
Your answer should be very brief. 8.41. In the year 1998, what is the difference between the Debt(% of exports of goods, services and primary income) in Bangladesh and Debt(% of exports of goods, services and primary income) in Egypt, Arab Rep.?
Keep it short and to the point. -0.86. In the year 1998, what is the difference between the Debt(% of exports of goods, services and primary income) in Belarus and Debt(% of exports of goods, services and primary income) in Egypt, Arab Rep.?
Your answer should be compact. -9.27. In the year 1999, what is the difference between the Debt(% of exports of goods, services and primary income) in Bangladesh and Debt(% of exports of goods, services and primary income) in Belarus?
Give a very brief answer. 7.49. In the year 1999, what is the difference between the Debt(% of exports of goods, services and primary income) of Bangladesh and Debt(% of exports of goods, services and primary income) of Egypt, Arab Rep.?
Make the answer very short. 0.89. In the year 1999, what is the difference between the Debt(% of exports of goods, services and primary income) of Belarus and Debt(% of exports of goods, services and primary income) of Egypt, Arab Rep.?
Keep it short and to the point. -6.6. In the year 2000, what is the difference between the Debt(% of exports of goods, services and primary income) of Bangladesh and Debt(% of exports of goods, services and primary income) of Belarus?
Your answer should be very brief. 7.09. In the year 2000, what is the difference between the Debt(% of exports of goods, services and primary income) in Bangladesh and Debt(% of exports of goods, services and primary income) in Egypt, Arab Rep.?
Provide a short and direct response. 1.74. In the year 2000, what is the difference between the Debt(% of exports of goods, services and primary income) of Belarus and Debt(% of exports of goods, services and primary income) of Egypt, Arab Rep.?
Provide a short and direct response. -5.35. What is the ratio of the Debt(% of exports of goods, services and primary income) of Bangladesh in 1993 to that in 1994?
Your answer should be very brief. 1.12. What is the ratio of the Debt(% of exports of goods, services and primary income) in Belarus in 1993 to that in 1994?
Ensure brevity in your answer.  0.16. What is the ratio of the Debt(% of exports of goods, services and primary income) in Egypt, Arab Rep. in 1993 to that in 1994?
Provide a short and direct response. 1.07. What is the ratio of the Debt(% of exports of goods, services and primary income) of Bangladesh in 1993 to that in 1995?
Your answer should be compact. 1.02. What is the ratio of the Debt(% of exports of goods, services and primary income) of Belarus in 1993 to that in 1995?
Make the answer very short. 0.19. What is the ratio of the Debt(% of exports of goods, services and primary income) in Egypt, Arab Rep. in 1993 to that in 1995?
Provide a short and direct response. 1.03. What is the ratio of the Debt(% of exports of goods, services and primary income) of Bangladesh in 1993 to that in 1996?
Make the answer very short. 1.2. What is the ratio of the Debt(% of exports of goods, services and primary income) in Belarus in 1993 to that in 1996?
Offer a terse response. 0.4. What is the ratio of the Debt(% of exports of goods, services and primary income) of Egypt, Arab Rep. in 1993 to that in 1996?
Ensure brevity in your answer.  1.19. What is the ratio of the Debt(% of exports of goods, services and primary income) of Bangladesh in 1993 to that in 1997?
Give a very brief answer. 1.38. What is the ratio of the Debt(% of exports of goods, services and primary income) in Belarus in 1993 to that in 1997?
Keep it short and to the point. 0.38. What is the ratio of the Debt(% of exports of goods, services and primary income) of Egypt, Arab Rep. in 1993 to that in 1997?
Provide a short and direct response. 1.44. What is the ratio of the Debt(% of exports of goods, services and primary income) in Bangladesh in 1993 to that in 1998?
Your answer should be very brief. 1.57. What is the ratio of the Debt(% of exports of goods, services and primary income) in Belarus in 1993 to that in 1998?
Offer a very short reply. 0.34. What is the ratio of the Debt(% of exports of goods, services and primary income) of Egypt, Arab Rep. in 1993 to that in 1998?
Your response must be concise. 1.34. What is the ratio of the Debt(% of exports of goods, services and primary income) of Bangladesh in 1993 to that in 1999?
Your response must be concise. 1.49. What is the ratio of the Debt(% of exports of goods, services and primary income) of Belarus in 1993 to that in 1999?
Your response must be concise. 0.19. What is the ratio of the Debt(% of exports of goods, services and primary income) of Egypt, Arab Rep. in 1993 to that in 1999?
Make the answer very short. 1.5. What is the ratio of the Debt(% of exports of goods, services and primary income) in Bangladesh in 1993 to that in 2000?
Keep it short and to the point. 1.58. What is the ratio of the Debt(% of exports of goods, services and primary income) of Belarus in 1993 to that in 2000?
Offer a terse response. 0.2. What is the ratio of the Debt(% of exports of goods, services and primary income) of Egypt, Arab Rep. in 1993 to that in 2000?
Your response must be concise. 1.76. What is the ratio of the Debt(% of exports of goods, services and primary income) of Bangladesh in 1994 to that in 1995?
Ensure brevity in your answer.  0.91. What is the ratio of the Debt(% of exports of goods, services and primary income) in Belarus in 1994 to that in 1995?
Your answer should be compact. 1.24. What is the ratio of the Debt(% of exports of goods, services and primary income) of Egypt, Arab Rep. in 1994 to that in 1995?
Provide a short and direct response. 0.96. What is the ratio of the Debt(% of exports of goods, services and primary income) of Bangladesh in 1994 to that in 1996?
Provide a short and direct response. 1.08. What is the ratio of the Debt(% of exports of goods, services and primary income) in Belarus in 1994 to that in 1996?
Your answer should be very brief. 2.6. What is the ratio of the Debt(% of exports of goods, services and primary income) in Egypt, Arab Rep. in 1994 to that in 1996?
Your answer should be very brief. 1.11. What is the ratio of the Debt(% of exports of goods, services and primary income) in Bangladesh in 1994 to that in 1997?
Make the answer very short. 1.23. What is the ratio of the Debt(% of exports of goods, services and primary income) of Belarus in 1994 to that in 1997?
Provide a succinct answer. 2.47. What is the ratio of the Debt(% of exports of goods, services and primary income) of Egypt, Arab Rep. in 1994 to that in 1997?
Keep it short and to the point. 1.34. What is the ratio of the Debt(% of exports of goods, services and primary income) in Bangladesh in 1994 to that in 1998?
Provide a succinct answer. 1.4. What is the ratio of the Debt(% of exports of goods, services and primary income) of Belarus in 1994 to that in 1998?
Give a very brief answer. 2.18. What is the ratio of the Debt(% of exports of goods, services and primary income) in Egypt, Arab Rep. in 1994 to that in 1998?
Keep it short and to the point. 1.25. What is the ratio of the Debt(% of exports of goods, services and primary income) in Bangladesh in 1994 to that in 1999?
Make the answer very short. 1.34. What is the ratio of the Debt(% of exports of goods, services and primary income) of Belarus in 1994 to that in 1999?
Offer a terse response. 1.24. What is the ratio of the Debt(% of exports of goods, services and primary income) of Egypt, Arab Rep. in 1994 to that in 1999?
Offer a very short reply. 1.4. What is the ratio of the Debt(% of exports of goods, services and primary income) in Bangladesh in 1994 to that in 2000?
Provide a succinct answer. 1.41. What is the ratio of the Debt(% of exports of goods, services and primary income) of Belarus in 1994 to that in 2000?
Provide a short and direct response. 1.32. What is the ratio of the Debt(% of exports of goods, services and primary income) in Egypt, Arab Rep. in 1994 to that in 2000?
Make the answer very short. 1.64. What is the ratio of the Debt(% of exports of goods, services and primary income) of Bangladesh in 1995 to that in 1996?
Provide a short and direct response. 1.18. What is the ratio of the Debt(% of exports of goods, services and primary income) in Belarus in 1995 to that in 1996?
Provide a succinct answer. 2.1. What is the ratio of the Debt(% of exports of goods, services and primary income) in Egypt, Arab Rep. in 1995 to that in 1996?
Provide a succinct answer. 1.16. What is the ratio of the Debt(% of exports of goods, services and primary income) of Bangladesh in 1995 to that in 1997?
Provide a short and direct response. 1.35. What is the ratio of the Debt(% of exports of goods, services and primary income) of Belarus in 1995 to that in 1997?
Make the answer very short. 2. What is the ratio of the Debt(% of exports of goods, services and primary income) in Egypt, Arab Rep. in 1995 to that in 1997?
Ensure brevity in your answer.  1.4. What is the ratio of the Debt(% of exports of goods, services and primary income) of Bangladesh in 1995 to that in 1998?
Offer a very short reply. 1.54. What is the ratio of the Debt(% of exports of goods, services and primary income) of Belarus in 1995 to that in 1998?
Offer a very short reply. 1.76. What is the ratio of the Debt(% of exports of goods, services and primary income) in Egypt, Arab Rep. in 1995 to that in 1998?
Offer a very short reply. 1.3. What is the ratio of the Debt(% of exports of goods, services and primary income) of Bangladesh in 1995 to that in 1999?
Ensure brevity in your answer.  1.46. What is the ratio of the Debt(% of exports of goods, services and primary income) in Egypt, Arab Rep. in 1995 to that in 1999?
Your response must be concise. 1.47. What is the ratio of the Debt(% of exports of goods, services and primary income) in Bangladesh in 1995 to that in 2000?
Make the answer very short. 1.55. What is the ratio of the Debt(% of exports of goods, services and primary income) in Belarus in 1995 to that in 2000?
Your answer should be compact. 1.07. What is the ratio of the Debt(% of exports of goods, services and primary income) of Egypt, Arab Rep. in 1995 to that in 2000?
Keep it short and to the point. 1.71. What is the ratio of the Debt(% of exports of goods, services and primary income) of Bangladesh in 1996 to that in 1997?
Ensure brevity in your answer.  1.14. What is the ratio of the Debt(% of exports of goods, services and primary income) in Belarus in 1996 to that in 1997?
Offer a very short reply. 0.95. What is the ratio of the Debt(% of exports of goods, services and primary income) in Egypt, Arab Rep. in 1996 to that in 1997?
Ensure brevity in your answer.  1.21. What is the ratio of the Debt(% of exports of goods, services and primary income) of Bangladesh in 1996 to that in 1998?
Offer a terse response. 1.3. What is the ratio of the Debt(% of exports of goods, services and primary income) in Belarus in 1996 to that in 1998?
Make the answer very short. 0.84. What is the ratio of the Debt(% of exports of goods, services and primary income) in Egypt, Arab Rep. in 1996 to that in 1998?
Keep it short and to the point. 1.12. What is the ratio of the Debt(% of exports of goods, services and primary income) in Bangladesh in 1996 to that in 1999?
Give a very brief answer. 1.24. What is the ratio of the Debt(% of exports of goods, services and primary income) of Belarus in 1996 to that in 1999?
Your answer should be compact. 0.48. What is the ratio of the Debt(% of exports of goods, services and primary income) of Egypt, Arab Rep. in 1996 to that in 1999?
Provide a succinct answer. 1.26. What is the ratio of the Debt(% of exports of goods, services and primary income) of Bangladesh in 1996 to that in 2000?
Give a very brief answer. 1.31. What is the ratio of the Debt(% of exports of goods, services and primary income) in Belarus in 1996 to that in 2000?
Your answer should be compact. 0.51. What is the ratio of the Debt(% of exports of goods, services and primary income) of Egypt, Arab Rep. in 1996 to that in 2000?
Your answer should be very brief. 1.47. What is the ratio of the Debt(% of exports of goods, services and primary income) of Bangladesh in 1997 to that in 1998?
Offer a very short reply. 1.14. What is the ratio of the Debt(% of exports of goods, services and primary income) of Belarus in 1997 to that in 1998?
Your response must be concise. 0.88. What is the ratio of the Debt(% of exports of goods, services and primary income) of Egypt, Arab Rep. in 1997 to that in 1998?
Provide a succinct answer. 0.93. What is the ratio of the Debt(% of exports of goods, services and primary income) of Bangladesh in 1997 to that in 1999?
Offer a terse response. 1.08. What is the ratio of the Debt(% of exports of goods, services and primary income) of Belarus in 1997 to that in 1999?
Your response must be concise. 0.5. What is the ratio of the Debt(% of exports of goods, services and primary income) in Egypt, Arab Rep. in 1997 to that in 1999?
Provide a succinct answer. 1.04. What is the ratio of the Debt(% of exports of goods, services and primary income) of Bangladesh in 1997 to that in 2000?
Offer a very short reply. 1.15. What is the ratio of the Debt(% of exports of goods, services and primary income) of Belarus in 1997 to that in 2000?
Your answer should be compact. 0.53. What is the ratio of the Debt(% of exports of goods, services and primary income) in Egypt, Arab Rep. in 1997 to that in 2000?
Provide a succinct answer. 1.22. What is the ratio of the Debt(% of exports of goods, services and primary income) in Belarus in 1998 to that in 1999?
Your answer should be compact. 0.57. What is the ratio of the Debt(% of exports of goods, services and primary income) in Egypt, Arab Rep. in 1998 to that in 1999?
Your answer should be very brief. 1.12. What is the ratio of the Debt(% of exports of goods, services and primary income) of Bangladesh in 1998 to that in 2000?
Your answer should be compact. 1.01. What is the ratio of the Debt(% of exports of goods, services and primary income) in Belarus in 1998 to that in 2000?
Your answer should be compact. 0.6. What is the ratio of the Debt(% of exports of goods, services and primary income) in Egypt, Arab Rep. in 1998 to that in 2000?
Keep it short and to the point. 1.31. What is the ratio of the Debt(% of exports of goods, services and primary income) of Bangladesh in 1999 to that in 2000?
Provide a succinct answer. 1.06. What is the ratio of the Debt(% of exports of goods, services and primary income) of Belarus in 1999 to that in 2000?
Provide a succinct answer. 1.06. What is the ratio of the Debt(% of exports of goods, services and primary income) in Egypt, Arab Rep. in 1999 to that in 2000?
Provide a succinct answer. 1.17. What is the difference between the highest and the second highest Debt(% of exports of goods, services and primary income) in Bangladesh?
Keep it short and to the point. 0.32. What is the difference between the highest and the second highest Debt(% of exports of goods, services and primary income) in Belarus?
Offer a very short reply. 0.79. What is the difference between the highest and the second highest Debt(% of exports of goods, services and primary income) of Egypt, Arab Rep.?
Your answer should be very brief. 0.38. What is the difference between the highest and the lowest Debt(% of exports of goods, services and primary income) of Bangladesh?
Offer a terse response. 5.93. What is the difference between the highest and the lowest Debt(% of exports of goods, services and primary income) in Belarus?
Ensure brevity in your answer.  3.51. What is the difference between the highest and the lowest Debt(% of exports of goods, services and primary income) in Egypt, Arab Rep.?
Make the answer very short. 6.44. 